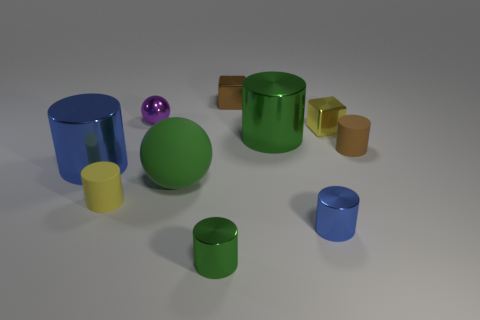Is the number of cubes that are left of the tiny blue metal cylinder less than the number of shiny things on the right side of the purple metallic object?
Give a very brief answer. Yes. There is a metal sphere; is it the same size as the blue object left of the large green rubber thing?
Your answer should be compact. No. What is the shape of the object that is both on the left side of the tiny purple shiny thing and behind the tiny yellow matte cylinder?
Provide a short and direct response. Cylinder. What is the size of the green object that is made of the same material as the small yellow cylinder?
Keep it short and to the point. Large. There is a yellow object on the right side of the small brown cube; what number of tiny brown cylinders are on the left side of it?
Offer a terse response. 0. Is the small cube in front of the purple sphere made of the same material as the tiny brown cylinder?
Offer a terse response. No. What size is the blue shiny object to the left of the large green thing that is right of the brown cube?
Your response must be concise. Large. What is the size of the blue metal cylinder that is on the left side of the green metallic object behind the blue metal cylinder that is left of the large green matte thing?
Provide a succinct answer. Large. Does the blue thing to the right of the tiny yellow cylinder have the same shape as the metal object that is to the left of the small purple object?
Provide a short and direct response. Yes. What number of other things are there of the same color as the rubber ball?
Provide a short and direct response. 2. 